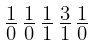<formula> <loc_0><loc_0><loc_500><loc_500>\begin{smallmatrix} 1 & 1 & 1 & 3 & 1 \\ \overline { 0 } & \overline { 0 } & \overline { 1 } & \overline { 1 } & \overline { 0 } \end{smallmatrix}</formula> 